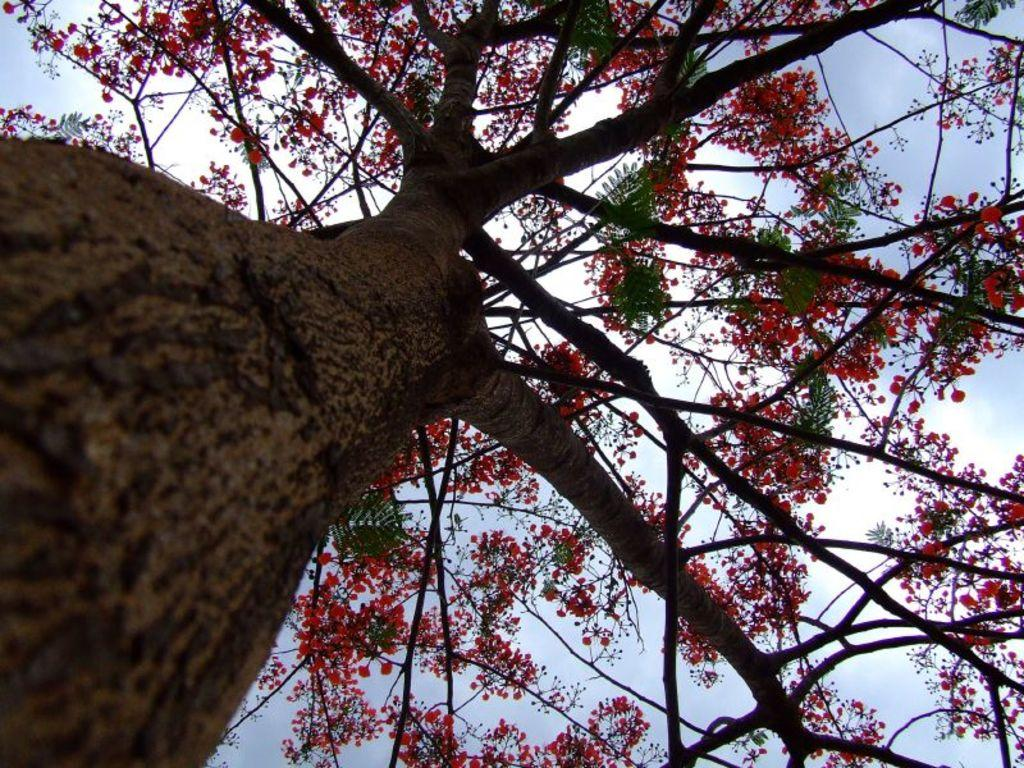What type of plant can be seen in the image? There is a tree in the image. What color are the flowers on the tree? The flowers on the tree are red. What is visible in the background of the image? The sky is visible in the image. What colors can be seen in the sky? The sky has a combination of white and blue colors. How many trucks are parked under the tree in the image? There are no trucks present in the image; it only features a tree with red flowers and a sky with white and blue colors. 